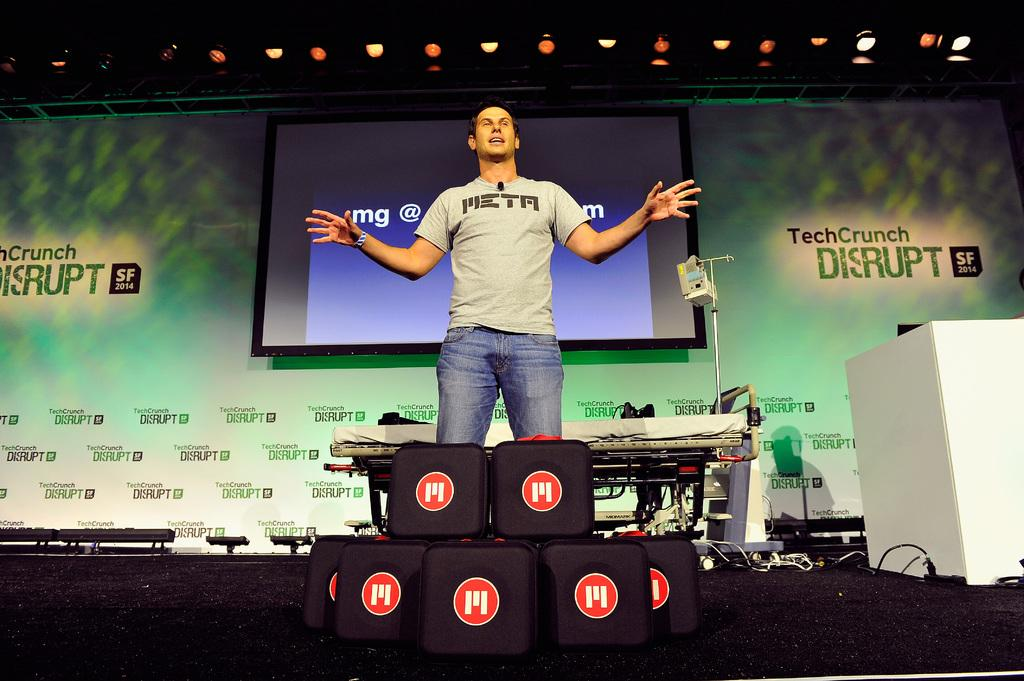What is the main subject of the image? The main subject of the image is a man standing. Can you describe what the man is wearing? The man is wearing clothes and a wristwatch. What objects or structures can be seen in the background of the image? There is a projected screen, a poster, a podium, a table, cable wires, and a box visible in the background. What type of surface is the man standing on? There is a floor visible in the image. How many fairies are flying around the man in the image? There are no fairies present in the image. Can you tell me how the man's wristwatch increases the time in the image? The wristwatch does not have the ability to increase time; it is simply a timekeeping device. 